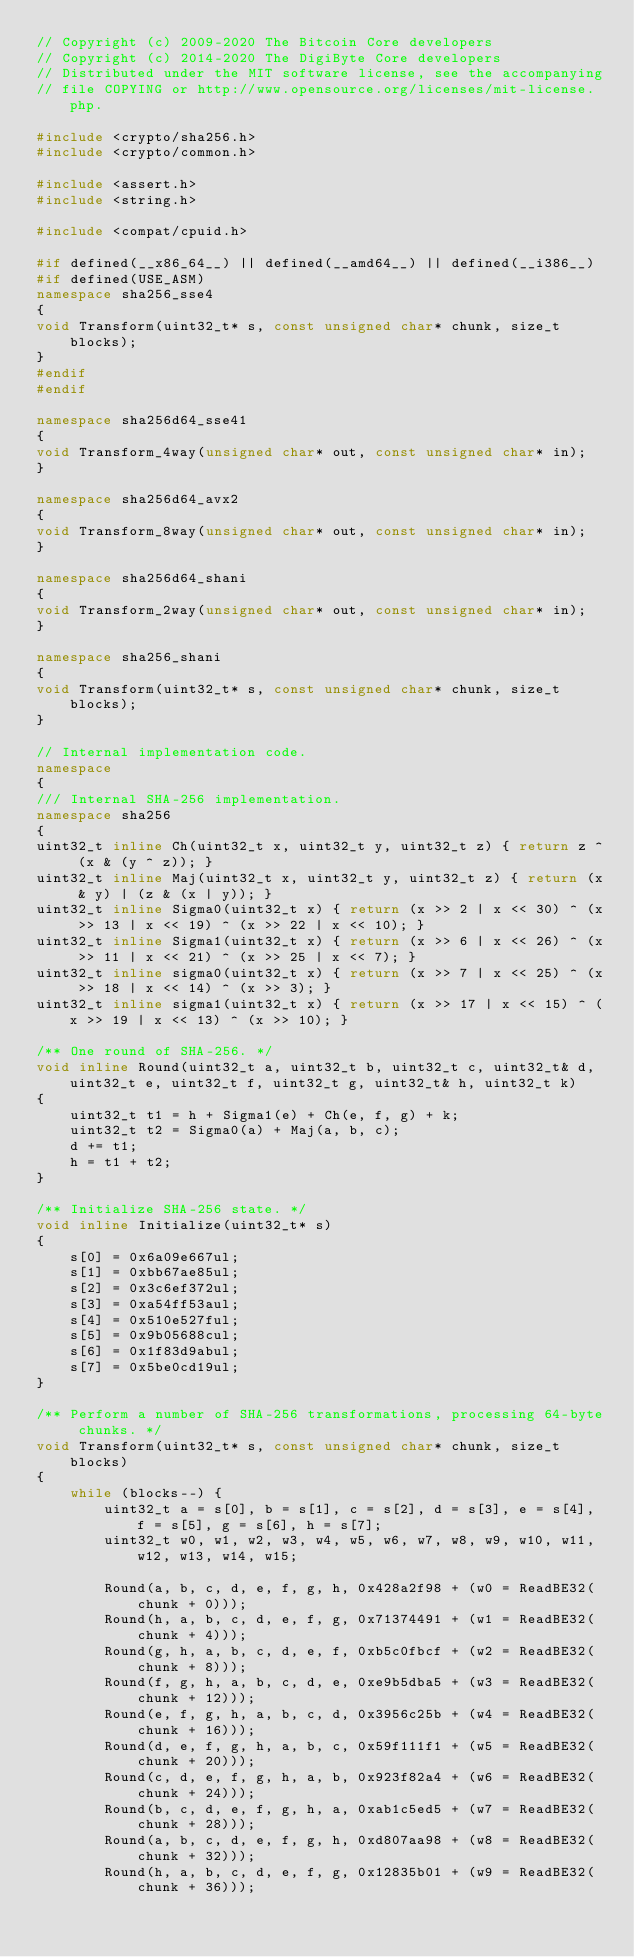Convert code to text. <code><loc_0><loc_0><loc_500><loc_500><_C++_>// Copyright (c) 2009-2020 The Bitcoin Core developers
// Copyright (c) 2014-2020 The DigiByte Core developers
// Distributed under the MIT software license, see the accompanying
// file COPYING or http://www.opensource.org/licenses/mit-license.php.

#include <crypto/sha256.h>
#include <crypto/common.h>

#include <assert.h>
#include <string.h>

#include <compat/cpuid.h>

#if defined(__x86_64__) || defined(__amd64__) || defined(__i386__)
#if defined(USE_ASM)
namespace sha256_sse4
{
void Transform(uint32_t* s, const unsigned char* chunk, size_t blocks);
}
#endif
#endif

namespace sha256d64_sse41
{
void Transform_4way(unsigned char* out, const unsigned char* in);
}

namespace sha256d64_avx2
{
void Transform_8way(unsigned char* out, const unsigned char* in);
}

namespace sha256d64_shani
{
void Transform_2way(unsigned char* out, const unsigned char* in);
}

namespace sha256_shani
{
void Transform(uint32_t* s, const unsigned char* chunk, size_t blocks);
}

// Internal implementation code.
namespace
{
/// Internal SHA-256 implementation.
namespace sha256
{
uint32_t inline Ch(uint32_t x, uint32_t y, uint32_t z) { return z ^ (x & (y ^ z)); }
uint32_t inline Maj(uint32_t x, uint32_t y, uint32_t z) { return (x & y) | (z & (x | y)); }
uint32_t inline Sigma0(uint32_t x) { return (x >> 2 | x << 30) ^ (x >> 13 | x << 19) ^ (x >> 22 | x << 10); }
uint32_t inline Sigma1(uint32_t x) { return (x >> 6 | x << 26) ^ (x >> 11 | x << 21) ^ (x >> 25 | x << 7); }
uint32_t inline sigma0(uint32_t x) { return (x >> 7 | x << 25) ^ (x >> 18 | x << 14) ^ (x >> 3); }
uint32_t inline sigma1(uint32_t x) { return (x >> 17 | x << 15) ^ (x >> 19 | x << 13) ^ (x >> 10); }

/** One round of SHA-256. */
void inline Round(uint32_t a, uint32_t b, uint32_t c, uint32_t& d, uint32_t e, uint32_t f, uint32_t g, uint32_t& h, uint32_t k)
{
    uint32_t t1 = h + Sigma1(e) + Ch(e, f, g) + k;
    uint32_t t2 = Sigma0(a) + Maj(a, b, c);
    d += t1;
    h = t1 + t2;
}

/** Initialize SHA-256 state. */
void inline Initialize(uint32_t* s)
{
    s[0] = 0x6a09e667ul;
    s[1] = 0xbb67ae85ul;
    s[2] = 0x3c6ef372ul;
    s[3] = 0xa54ff53aul;
    s[4] = 0x510e527ful;
    s[5] = 0x9b05688cul;
    s[6] = 0x1f83d9abul;
    s[7] = 0x5be0cd19ul;
}

/** Perform a number of SHA-256 transformations, processing 64-byte chunks. */
void Transform(uint32_t* s, const unsigned char* chunk, size_t blocks)
{
    while (blocks--) {
        uint32_t a = s[0], b = s[1], c = s[2], d = s[3], e = s[4], f = s[5], g = s[6], h = s[7];
        uint32_t w0, w1, w2, w3, w4, w5, w6, w7, w8, w9, w10, w11, w12, w13, w14, w15;

        Round(a, b, c, d, e, f, g, h, 0x428a2f98 + (w0 = ReadBE32(chunk + 0)));
        Round(h, a, b, c, d, e, f, g, 0x71374491 + (w1 = ReadBE32(chunk + 4)));
        Round(g, h, a, b, c, d, e, f, 0xb5c0fbcf + (w2 = ReadBE32(chunk + 8)));
        Round(f, g, h, a, b, c, d, e, 0xe9b5dba5 + (w3 = ReadBE32(chunk + 12)));
        Round(e, f, g, h, a, b, c, d, 0x3956c25b + (w4 = ReadBE32(chunk + 16)));
        Round(d, e, f, g, h, a, b, c, 0x59f111f1 + (w5 = ReadBE32(chunk + 20)));
        Round(c, d, e, f, g, h, a, b, 0x923f82a4 + (w6 = ReadBE32(chunk + 24)));
        Round(b, c, d, e, f, g, h, a, 0xab1c5ed5 + (w7 = ReadBE32(chunk + 28)));
        Round(a, b, c, d, e, f, g, h, 0xd807aa98 + (w8 = ReadBE32(chunk + 32)));
        Round(h, a, b, c, d, e, f, g, 0x12835b01 + (w9 = ReadBE32(chunk + 36)));</code> 